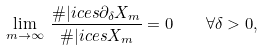<formula> <loc_0><loc_0><loc_500><loc_500>\lim _ { m \rightarrow \infty } \, \frac { \# { | i c e s \partial _ { \delta } X _ { m } } } { \# { | i c e s X _ { m } } } = 0 \quad \forall \delta > 0 ,</formula> 